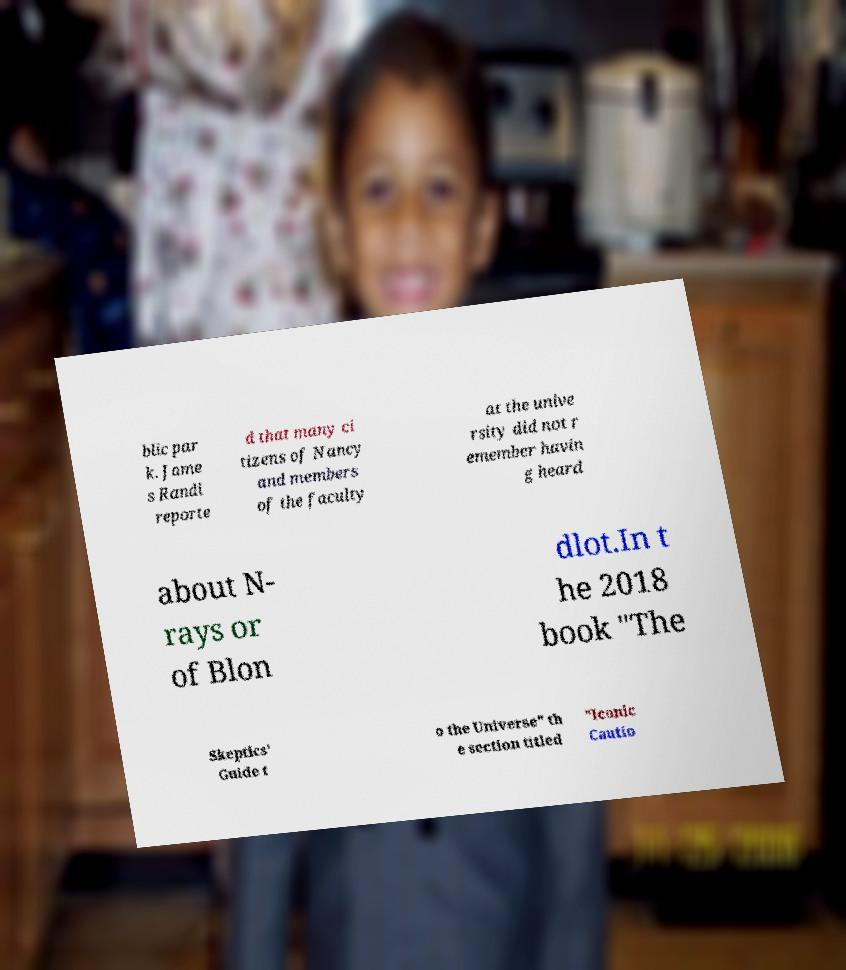I need the written content from this picture converted into text. Can you do that? blic par k. Jame s Randi reporte d that many ci tizens of Nancy and members of the faculty at the unive rsity did not r emember havin g heard about N- rays or of Blon dlot.In t he 2018 book "The Skeptics' Guide t o the Universe" th e section titled "Iconic Cautio 